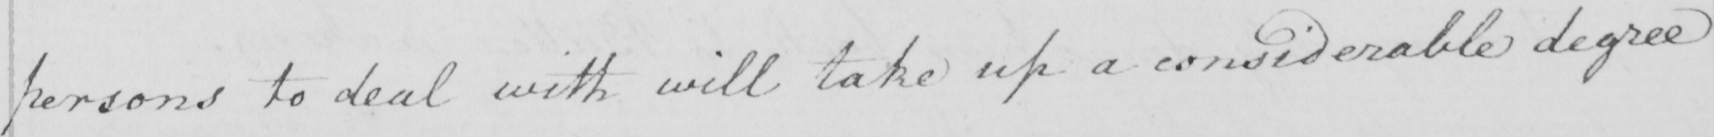Transcribe the text shown in this historical manuscript line. persons to deal with will take up a considerable degree 